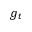<formula> <loc_0><loc_0><loc_500><loc_500>g _ { t }</formula> 